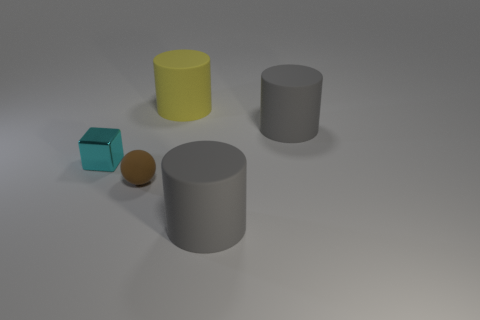Add 2 small green cylinders. How many objects exist? 7 Subtract all cylinders. How many objects are left? 2 Subtract 1 gray cylinders. How many objects are left? 4 Subtract all small red matte balls. Subtract all tiny cyan objects. How many objects are left? 4 Add 4 tiny cyan metallic cubes. How many tiny cyan metallic cubes are left? 5 Add 5 gray rubber cylinders. How many gray rubber cylinders exist? 7 